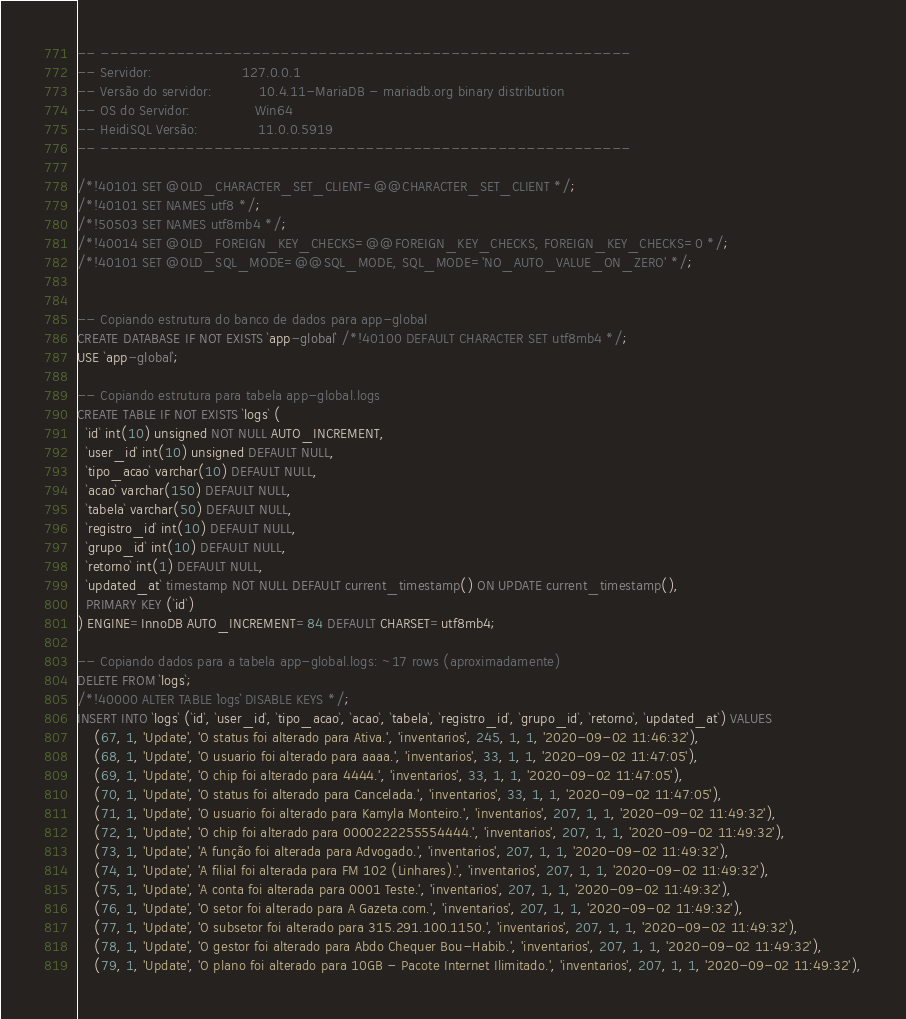<code> <loc_0><loc_0><loc_500><loc_500><_SQL_>-- --------------------------------------------------------
-- Servidor:                     127.0.0.1
-- Versão do servidor:           10.4.11-MariaDB - mariadb.org binary distribution
-- OS do Servidor:               Win64
-- HeidiSQL Versão:              11.0.0.5919
-- --------------------------------------------------------

/*!40101 SET @OLD_CHARACTER_SET_CLIENT=@@CHARACTER_SET_CLIENT */;
/*!40101 SET NAMES utf8 */;
/*!50503 SET NAMES utf8mb4 */;
/*!40014 SET @OLD_FOREIGN_KEY_CHECKS=@@FOREIGN_KEY_CHECKS, FOREIGN_KEY_CHECKS=0 */;
/*!40101 SET @OLD_SQL_MODE=@@SQL_MODE, SQL_MODE='NO_AUTO_VALUE_ON_ZERO' */;


-- Copiando estrutura do banco de dados para app-global
CREATE DATABASE IF NOT EXISTS `app-global` /*!40100 DEFAULT CHARACTER SET utf8mb4 */;
USE `app-global`;

-- Copiando estrutura para tabela app-global.logs
CREATE TABLE IF NOT EXISTS `logs` (
  `id` int(10) unsigned NOT NULL AUTO_INCREMENT,
  `user_id` int(10) unsigned DEFAULT NULL,
  `tipo_acao` varchar(10) DEFAULT NULL,
  `acao` varchar(150) DEFAULT NULL,
  `tabela` varchar(50) DEFAULT NULL,
  `registro_id` int(10) DEFAULT NULL,
  `grupo_id` int(10) DEFAULT NULL,
  `retorno` int(1) DEFAULT NULL,
  `updated_at` timestamp NOT NULL DEFAULT current_timestamp() ON UPDATE current_timestamp(),
  PRIMARY KEY (`id`)
) ENGINE=InnoDB AUTO_INCREMENT=84 DEFAULT CHARSET=utf8mb4;

-- Copiando dados para a tabela app-global.logs: ~17 rows (aproximadamente)
DELETE FROM `logs`;
/*!40000 ALTER TABLE `logs` DISABLE KEYS */;
INSERT INTO `logs` (`id`, `user_id`, `tipo_acao`, `acao`, `tabela`, `registro_id`, `grupo_id`, `retorno`, `updated_at`) VALUES
	(67, 1, 'Update', 'O status foi alterado para Ativa.', 'inventarios', 245, 1, 1, '2020-09-02 11:46:32'),
	(68, 1, 'Update', 'O usuario foi alterado para aaaa.', 'inventarios', 33, 1, 1, '2020-09-02 11:47:05'),
	(69, 1, 'Update', 'O chip foi alterado para 4444.', 'inventarios', 33, 1, 1, '2020-09-02 11:47:05'),
	(70, 1, 'Update', 'O status foi alterado para Cancelada.', 'inventarios', 33, 1, 1, '2020-09-02 11:47:05'),
	(71, 1, 'Update', 'O usuario foi alterado para Kamyla Monteiro.', 'inventarios', 207, 1, 1, '2020-09-02 11:49:32'),
	(72, 1, 'Update', 'O chip foi alterado para 0000222255554444.', 'inventarios', 207, 1, 1, '2020-09-02 11:49:32'),
	(73, 1, 'Update', 'A função foi alterada para Advogado.', 'inventarios', 207, 1, 1, '2020-09-02 11:49:32'),
	(74, 1, 'Update', 'A filial foi alterada para FM 102 (Linhares).', 'inventarios', 207, 1, 1, '2020-09-02 11:49:32'),
	(75, 1, 'Update', 'A conta foi alterada para 0001 Teste.', 'inventarios', 207, 1, 1, '2020-09-02 11:49:32'),
	(76, 1, 'Update', 'O setor foi alterado para A Gazeta.com.', 'inventarios', 207, 1, 1, '2020-09-02 11:49:32'),
	(77, 1, 'Update', 'O subsetor foi alterado para 315.291.100.1150.', 'inventarios', 207, 1, 1, '2020-09-02 11:49:32'),
	(78, 1, 'Update', 'O gestor foi alterado para Abdo Chequer Bou-Habib.', 'inventarios', 207, 1, 1, '2020-09-02 11:49:32'),
	(79, 1, 'Update', 'O plano foi alterado para 10GB - Pacote Internet Ilimitado.', 'inventarios', 207, 1, 1, '2020-09-02 11:49:32'),</code> 